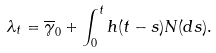<formula> <loc_0><loc_0><loc_500><loc_500>\lambda _ { t } = \overline { \gamma } _ { 0 } + \int _ { 0 } ^ { t } h ( t - s ) N ( d s ) .</formula> 